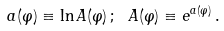<formula> <loc_0><loc_0><loc_500><loc_500>a ( \varphi ) \equiv \ln A ( \varphi ) \, ; \ A ( \varphi ) \equiv e ^ { a ( \varphi ) } \, .</formula> 